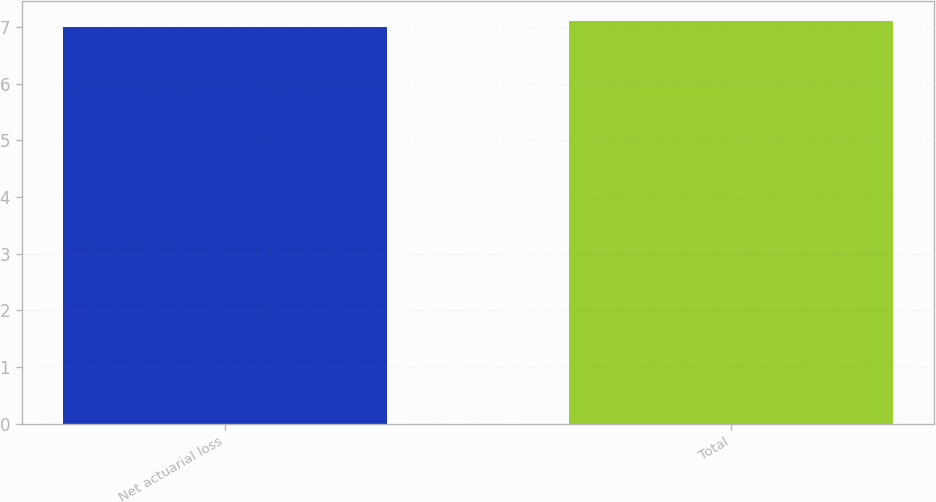Convert chart to OTSL. <chart><loc_0><loc_0><loc_500><loc_500><bar_chart><fcel>Net actuarial loss<fcel>Total<nl><fcel>7<fcel>7.1<nl></chart> 